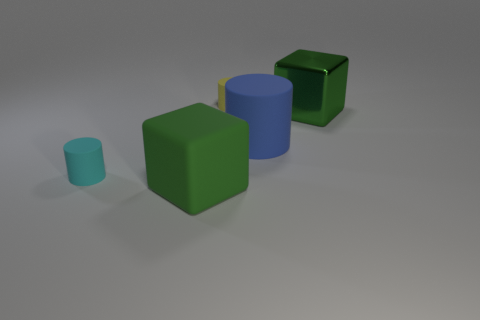Add 5 blue rubber objects. How many objects exist? 10 Subtract all cubes. How many objects are left? 3 Add 4 rubber blocks. How many rubber blocks exist? 5 Subtract 0 green spheres. How many objects are left? 5 Subtract all yellow cylinders. Subtract all yellow things. How many objects are left? 3 Add 3 cubes. How many cubes are left? 5 